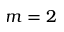<formula> <loc_0><loc_0><loc_500><loc_500>m = 2</formula> 